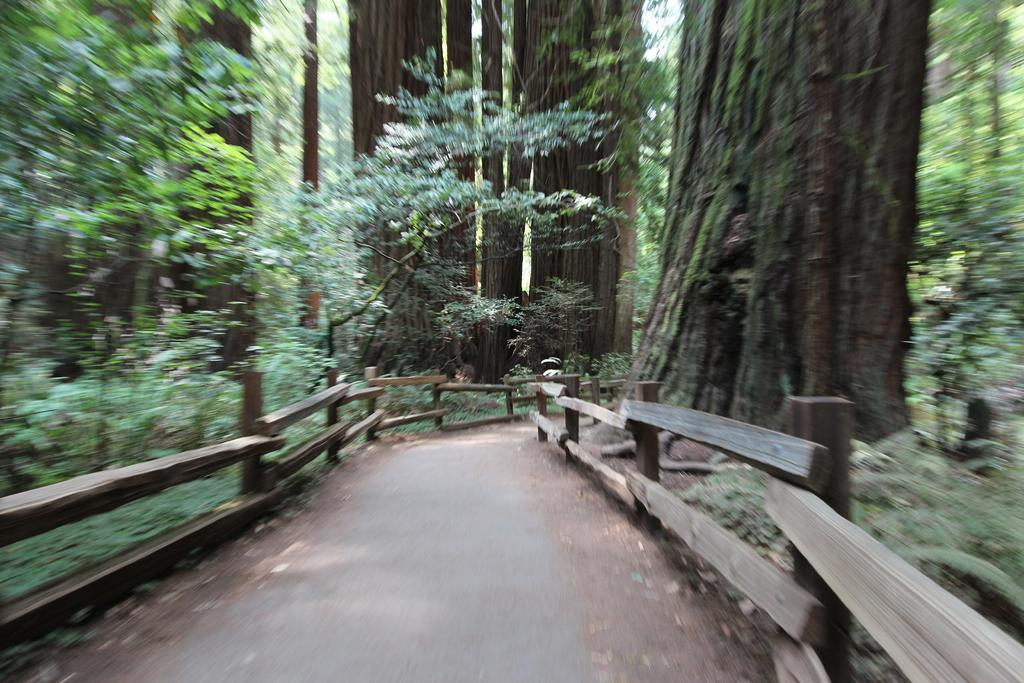What is the main feature in the foreground of the image? There is a path in the image, and it is in the front of the image. What surrounds the path on both sides? There is a fence on either side of the path. What can be seen in the background of the image? There are trees in the background of the image. How are the trees distributed in the background? The trees are present all over the place in the background. How many heads of steam can be seen coming from the trees in the image? There is no steam present in the image; it features a path, fences, and trees. 